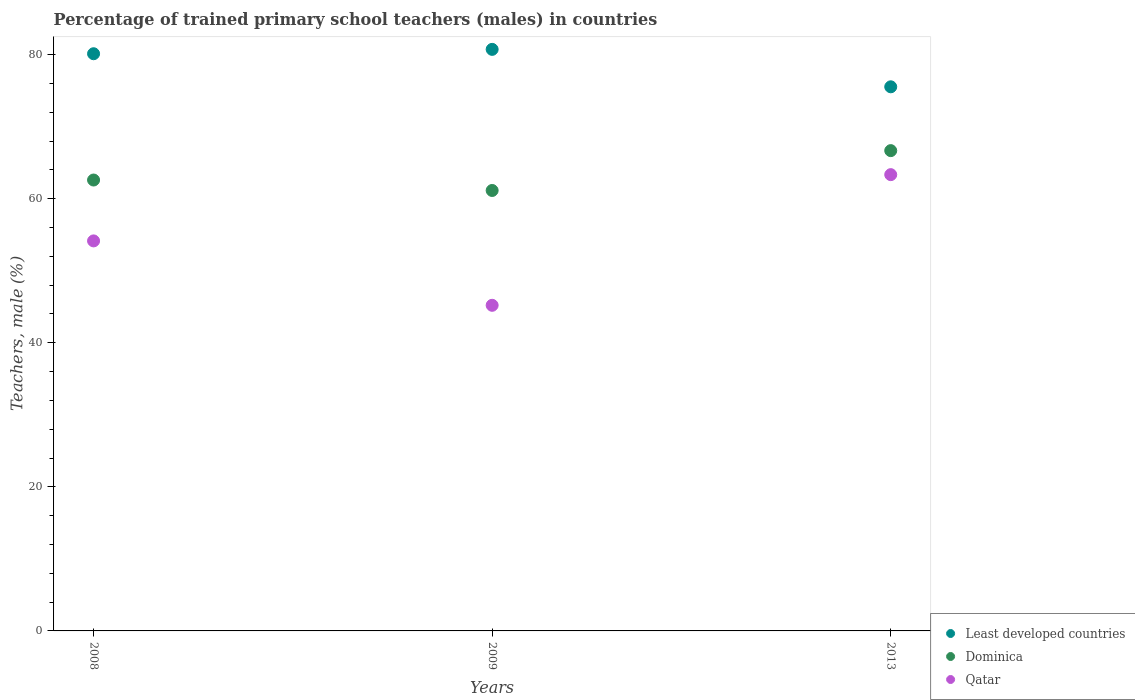How many different coloured dotlines are there?
Offer a very short reply. 3. What is the percentage of trained primary school teachers (males) in Qatar in 2008?
Ensure brevity in your answer.  54.14. Across all years, what is the maximum percentage of trained primary school teachers (males) in Qatar?
Offer a terse response. 63.33. Across all years, what is the minimum percentage of trained primary school teachers (males) in Dominica?
Keep it short and to the point. 61.14. In which year was the percentage of trained primary school teachers (males) in Dominica minimum?
Your response must be concise. 2009. What is the total percentage of trained primary school teachers (males) in Least developed countries in the graph?
Give a very brief answer. 236.37. What is the difference between the percentage of trained primary school teachers (males) in Dominica in 2008 and that in 2009?
Offer a terse response. 1.45. What is the difference between the percentage of trained primary school teachers (males) in Qatar in 2013 and the percentage of trained primary school teachers (males) in Dominica in 2008?
Your response must be concise. 0.75. What is the average percentage of trained primary school teachers (males) in Qatar per year?
Keep it short and to the point. 54.22. In the year 2013, what is the difference between the percentage of trained primary school teachers (males) in Least developed countries and percentage of trained primary school teachers (males) in Dominica?
Keep it short and to the point. 8.86. What is the ratio of the percentage of trained primary school teachers (males) in Qatar in 2008 to that in 2009?
Offer a terse response. 1.2. What is the difference between the highest and the second highest percentage of trained primary school teachers (males) in Dominica?
Your answer should be compact. 4.08. What is the difference between the highest and the lowest percentage of trained primary school teachers (males) in Qatar?
Provide a short and direct response. 18.14. How many years are there in the graph?
Your answer should be compact. 3. Does the graph contain any zero values?
Offer a terse response. No. Does the graph contain grids?
Make the answer very short. No. Where does the legend appear in the graph?
Your answer should be very brief. Bottom right. How many legend labels are there?
Your answer should be compact. 3. How are the legend labels stacked?
Ensure brevity in your answer.  Vertical. What is the title of the graph?
Ensure brevity in your answer.  Percentage of trained primary school teachers (males) in countries. What is the label or title of the X-axis?
Your answer should be very brief. Years. What is the label or title of the Y-axis?
Ensure brevity in your answer.  Teachers, male (%). What is the Teachers, male (%) of Least developed countries in 2008?
Provide a succinct answer. 80.12. What is the Teachers, male (%) in Dominica in 2008?
Provide a succinct answer. 62.59. What is the Teachers, male (%) in Qatar in 2008?
Provide a succinct answer. 54.14. What is the Teachers, male (%) of Least developed countries in 2009?
Provide a succinct answer. 80.72. What is the Teachers, male (%) of Dominica in 2009?
Provide a succinct answer. 61.14. What is the Teachers, male (%) in Qatar in 2009?
Provide a short and direct response. 45.2. What is the Teachers, male (%) in Least developed countries in 2013?
Provide a short and direct response. 75.53. What is the Teachers, male (%) of Dominica in 2013?
Give a very brief answer. 66.67. What is the Teachers, male (%) in Qatar in 2013?
Keep it short and to the point. 63.33. Across all years, what is the maximum Teachers, male (%) of Least developed countries?
Provide a short and direct response. 80.72. Across all years, what is the maximum Teachers, male (%) of Dominica?
Your response must be concise. 66.67. Across all years, what is the maximum Teachers, male (%) of Qatar?
Ensure brevity in your answer.  63.33. Across all years, what is the minimum Teachers, male (%) of Least developed countries?
Give a very brief answer. 75.53. Across all years, what is the minimum Teachers, male (%) in Dominica?
Offer a terse response. 61.14. Across all years, what is the minimum Teachers, male (%) in Qatar?
Make the answer very short. 45.2. What is the total Teachers, male (%) in Least developed countries in the graph?
Make the answer very short. 236.37. What is the total Teachers, male (%) in Dominica in the graph?
Provide a succinct answer. 190.39. What is the total Teachers, male (%) in Qatar in the graph?
Your response must be concise. 162.67. What is the difference between the Teachers, male (%) in Least developed countries in 2008 and that in 2009?
Offer a terse response. -0.61. What is the difference between the Teachers, male (%) in Dominica in 2008 and that in 2009?
Make the answer very short. 1.45. What is the difference between the Teachers, male (%) of Qatar in 2008 and that in 2009?
Offer a very short reply. 8.94. What is the difference between the Teachers, male (%) in Least developed countries in 2008 and that in 2013?
Keep it short and to the point. 4.59. What is the difference between the Teachers, male (%) of Dominica in 2008 and that in 2013?
Your response must be concise. -4.08. What is the difference between the Teachers, male (%) of Qatar in 2008 and that in 2013?
Your response must be concise. -9.2. What is the difference between the Teachers, male (%) of Least developed countries in 2009 and that in 2013?
Keep it short and to the point. 5.2. What is the difference between the Teachers, male (%) in Dominica in 2009 and that in 2013?
Make the answer very short. -5.53. What is the difference between the Teachers, male (%) in Qatar in 2009 and that in 2013?
Offer a very short reply. -18.14. What is the difference between the Teachers, male (%) in Least developed countries in 2008 and the Teachers, male (%) in Dominica in 2009?
Keep it short and to the point. 18.98. What is the difference between the Teachers, male (%) in Least developed countries in 2008 and the Teachers, male (%) in Qatar in 2009?
Make the answer very short. 34.92. What is the difference between the Teachers, male (%) in Dominica in 2008 and the Teachers, male (%) in Qatar in 2009?
Your answer should be compact. 17.39. What is the difference between the Teachers, male (%) of Least developed countries in 2008 and the Teachers, male (%) of Dominica in 2013?
Make the answer very short. 13.45. What is the difference between the Teachers, male (%) of Least developed countries in 2008 and the Teachers, male (%) of Qatar in 2013?
Make the answer very short. 16.78. What is the difference between the Teachers, male (%) of Dominica in 2008 and the Teachers, male (%) of Qatar in 2013?
Keep it short and to the point. -0.75. What is the difference between the Teachers, male (%) in Least developed countries in 2009 and the Teachers, male (%) in Dominica in 2013?
Provide a short and direct response. 14.06. What is the difference between the Teachers, male (%) in Least developed countries in 2009 and the Teachers, male (%) in Qatar in 2013?
Provide a succinct answer. 17.39. What is the difference between the Teachers, male (%) in Dominica in 2009 and the Teachers, male (%) in Qatar in 2013?
Provide a short and direct response. -2.2. What is the average Teachers, male (%) in Least developed countries per year?
Make the answer very short. 78.79. What is the average Teachers, male (%) of Dominica per year?
Your answer should be very brief. 63.46. What is the average Teachers, male (%) of Qatar per year?
Make the answer very short. 54.22. In the year 2008, what is the difference between the Teachers, male (%) in Least developed countries and Teachers, male (%) in Dominica?
Provide a succinct answer. 17.53. In the year 2008, what is the difference between the Teachers, male (%) in Least developed countries and Teachers, male (%) in Qatar?
Ensure brevity in your answer.  25.98. In the year 2008, what is the difference between the Teachers, male (%) of Dominica and Teachers, male (%) of Qatar?
Your answer should be compact. 8.45. In the year 2009, what is the difference between the Teachers, male (%) in Least developed countries and Teachers, male (%) in Dominica?
Keep it short and to the point. 19.59. In the year 2009, what is the difference between the Teachers, male (%) in Least developed countries and Teachers, male (%) in Qatar?
Offer a terse response. 35.53. In the year 2009, what is the difference between the Teachers, male (%) in Dominica and Teachers, male (%) in Qatar?
Give a very brief answer. 15.94. In the year 2013, what is the difference between the Teachers, male (%) in Least developed countries and Teachers, male (%) in Dominica?
Your response must be concise. 8.86. In the year 2013, what is the difference between the Teachers, male (%) in Least developed countries and Teachers, male (%) in Qatar?
Keep it short and to the point. 12.19. What is the ratio of the Teachers, male (%) of Dominica in 2008 to that in 2009?
Offer a very short reply. 1.02. What is the ratio of the Teachers, male (%) in Qatar in 2008 to that in 2009?
Provide a succinct answer. 1.2. What is the ratio of the Teachers, male (%) in Least developed countries in 2008 to that in 2013?
Provide a succinct answer. 1.06. What is the ratio of the Teachers, male (%) of Dominica in 2008 to that in 2013?
Your answer should be compact. 0.94. What is the ratio of the Teachers, male (%) of Qatar in 2008 to that in 2013?
Make the answer very short. 0.85. What is the ratio of the Teachers, male (%) in Least developed countries in 2009 to that in 2013?
Offer a terse response. 1.07. What is the ratio of the Teachers, male (%) in Dominica in 2009 to that in 2013?
Offer a very short reply. 0.92. What is the ratio of the Teachers, male (%) in Qatar in 2009 to that in 2013?
Provide a succinct answer. 0.71. What is the difference between the highest and the second highest Teachers, male (%) in Least developed countries?
Your response must be concise. 0.61. What is the difference between the highest and the second highest Teachers, male (%) of Dominica?
Give a very brief answer. 4.08. What is the difference between the highest and the second highest Teachers, male (%) of Qatar?
Offer a very short reply. 9.2. What is the difference between the highest and the lowest Teachers, male (%) of Least developed countries?
Your answer should be very brief. 5.2. What is the difference between the highest and the lowest Teachers, male (%) in Dominica?
Provide a succinct answer. 5.53. What is the difference between the highest and the lowest Teachers, male (%) in Qatar?
Provide a short and direct response. 18.14. 